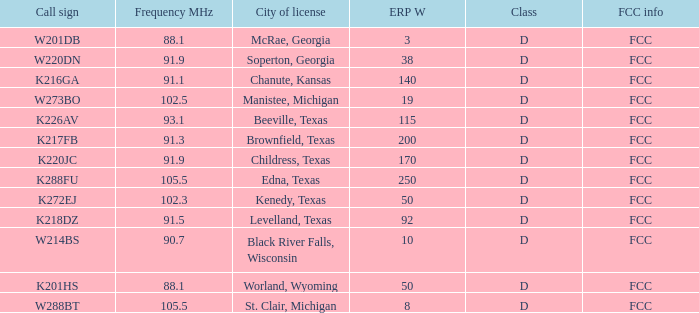What is the Sum of ERP W, when Call Sign is K216GA? 140.0. 